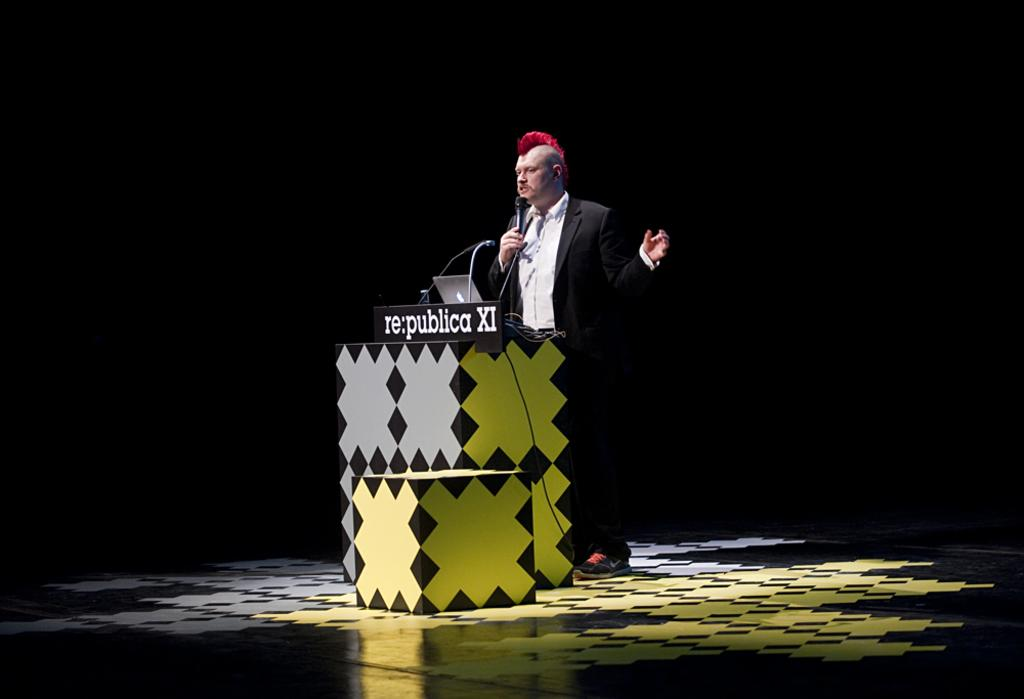What is the man in the image doing? The man is standing near a podium in the image. What object is the man holding in his hand? The man is holding a microphone in his hand. What is the man wearing in the image? The man is wearing a suit in the image. What device is in front of the man? There is a laptop in front of the man. What can be observed about the background of the image? The background of the image is dark. What type of pump is visible in the image? There is no pump present in the image. What role does the minister play in the image? There is no minister present in the image. 